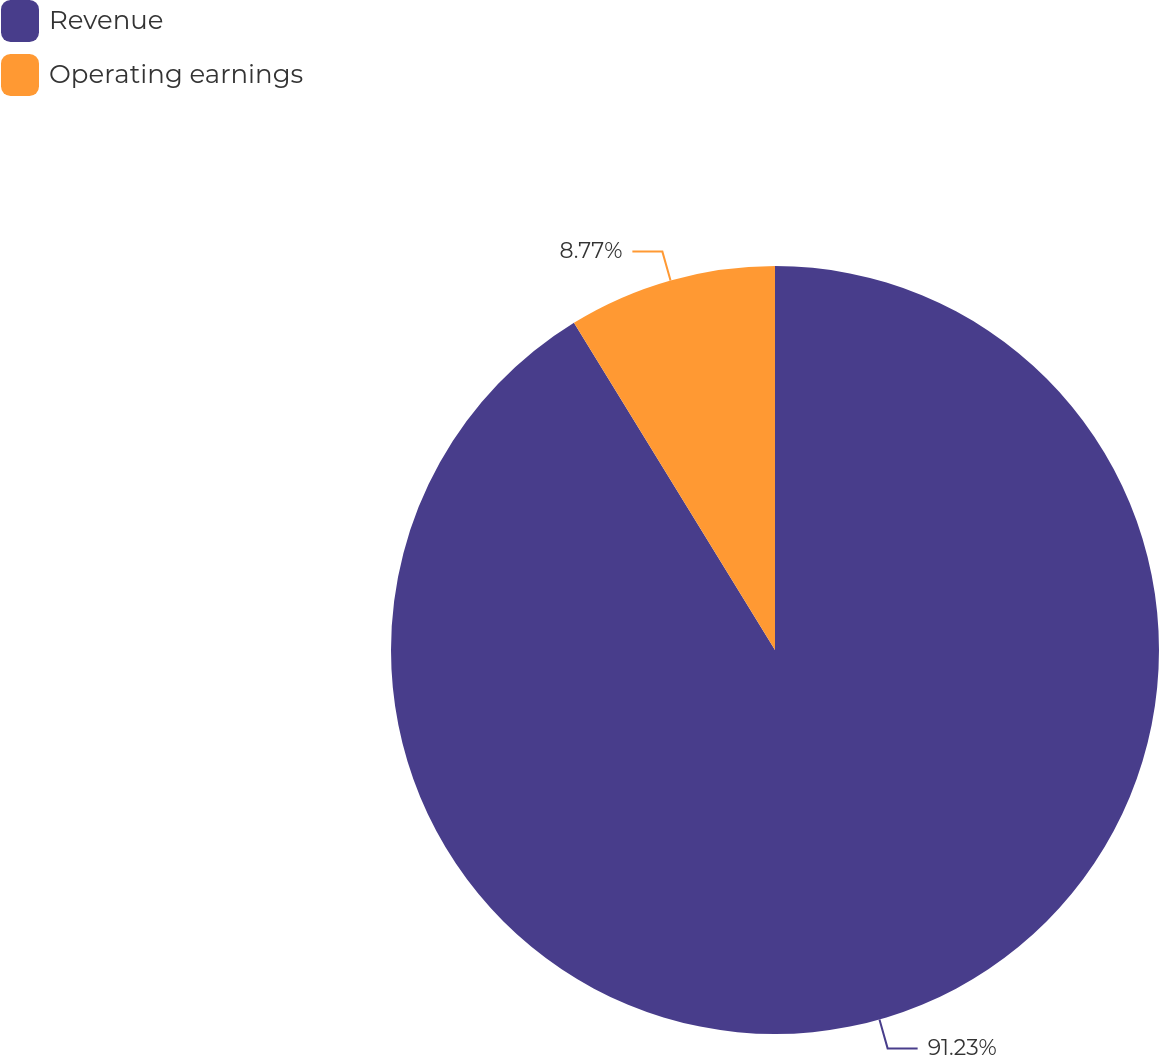Convert chart to OTSL. <chart><loc_0><loc_0><loc_500><loc_500><pie_chart><fcel>Revenue<fcel>Operating earnings<nl><fcel>91.23%<fcel>8.77%<nl></chart> 